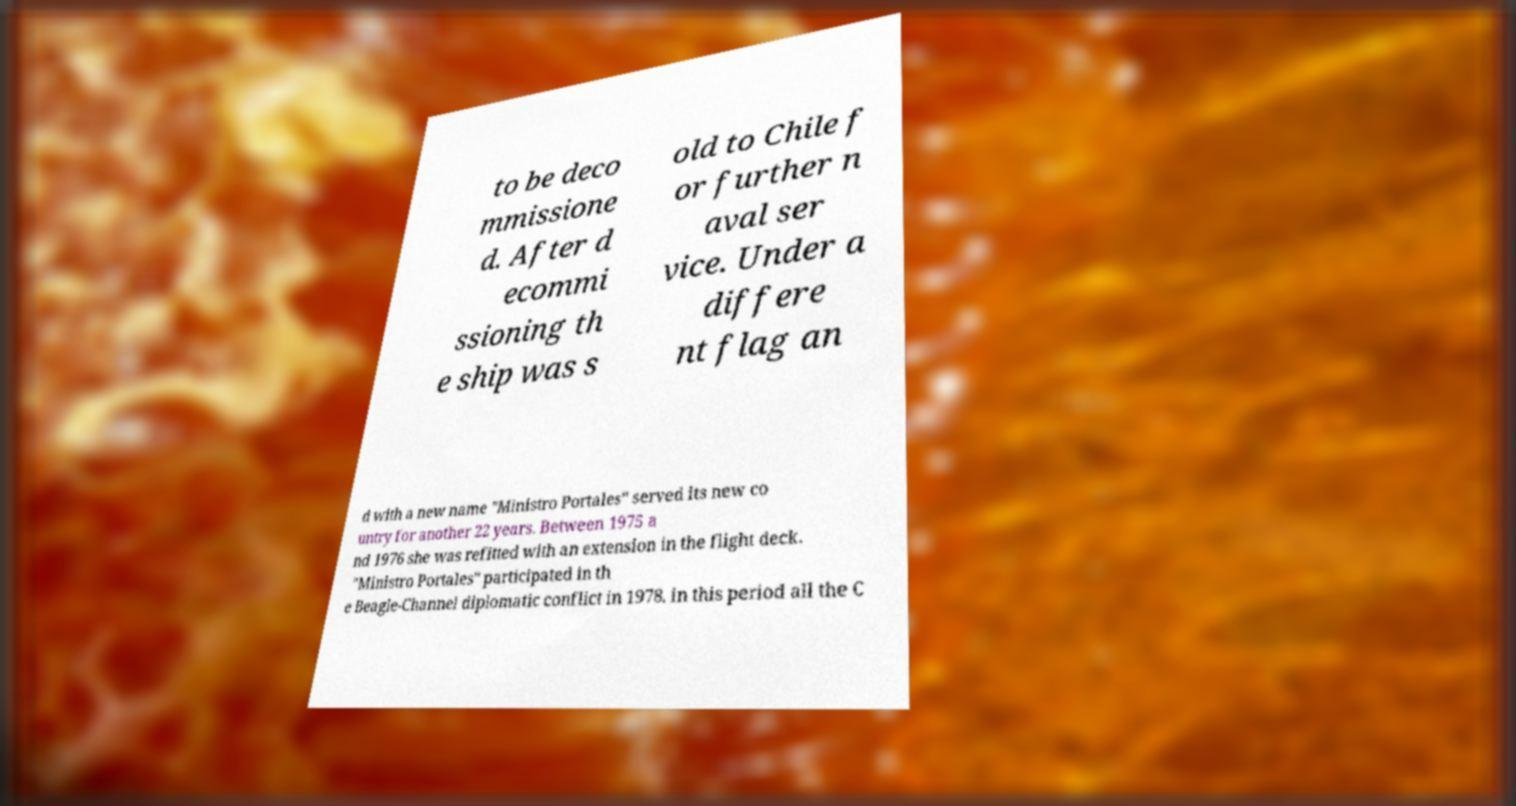For documentation purposes, I need the text within this image transcribed. Could you provide that? to be deco mmissione d. After d ecommi ssioning th e ship was s old to Chile f or further n aval ser vice. Under a differe nt flag an d with a new name "Ministro Portales" served its new co untry for another 22 years. Between 1975 a nd 1976 she was refitted with an extension in the flight deck. "Ministro Portales" participated in th e Beagle-Channel diplomatic conflict in 1978. in this period all the C 